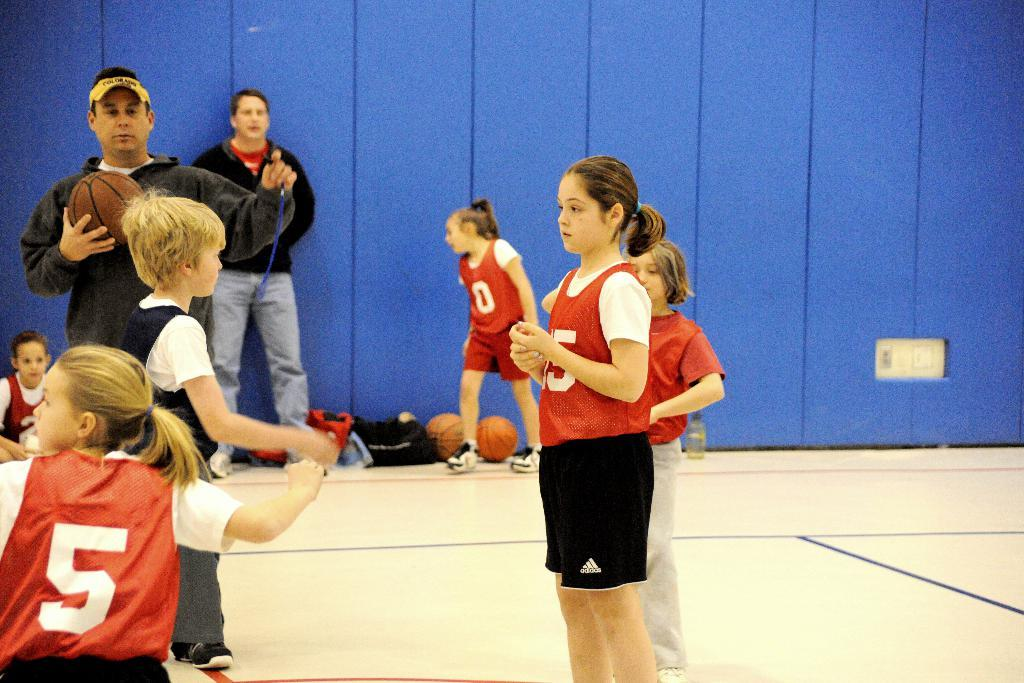Who is present in the image? There are children and men in the image. What are the children and men doing in the image? They are standing on the floor. What items can be seen with the children and men? Backpacks, sports balls, and water bottles are visible in the image. What type of rose can be seen in the hands of the children in the image? There are no roses present in the image; only children, men, backpacks, sports balls, and water bottles are visible. 